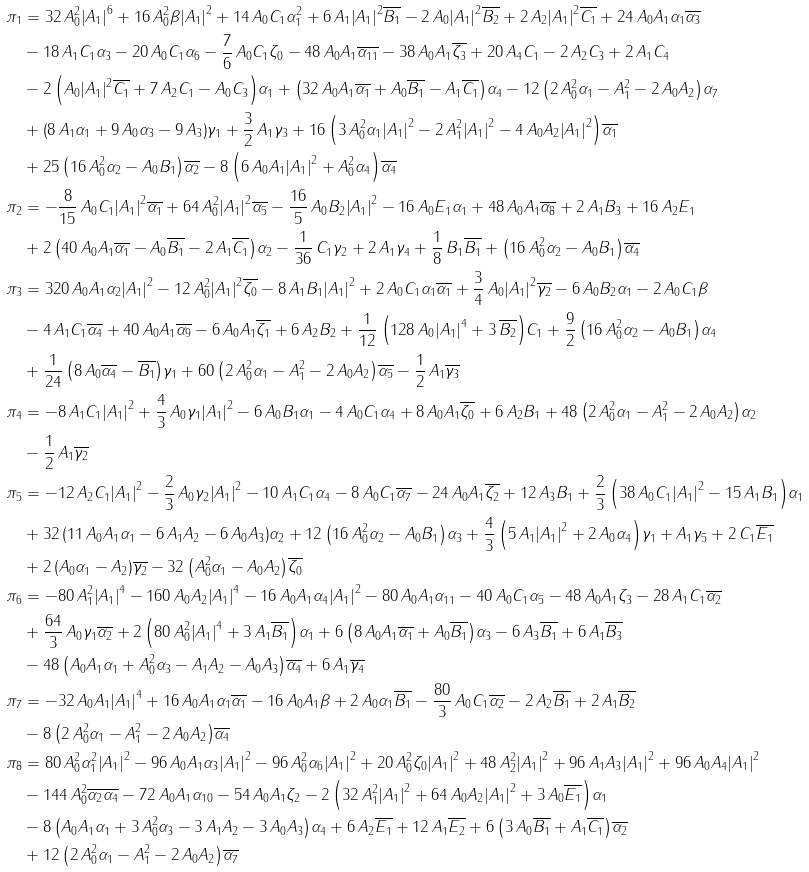<formula> <loc_0><loc_0><loc_500><loc_500>\pi _ { 1 } & = 3 2 \, A _ { 0 } ^ { 2 } { \left | A _ { 1 } \right | } ^ { 6 } + 1 6 \, A _ { 0 } ^ { 2 } \beta { \left | A _ { 1 } \right | } ^ { 2 } + 1 4 \, A _ { 0 } C _ { 1 } \alpha _ { 1 } ^ { 2 } + 6 \, A _ { 1 } { \left | A _ { 1 } \right | } ^ { 2 } \overline { B _ { 1 } } - 2 \, A _ { 0 } { \left | A _ { 1 } \right | } ^ { 2 } \overline { B _ { 2 } } + 2 \, A _ { 2 } { \left | A _ { 1 } \right | } ^ { 2 } \overline { C _ { 1 } } + 2 4 \, A _ { 0 } A _ { 1 } \alpha _ { 1 } \overline { \alpha _ { 3 } } \\ & - 1 8 \, A _ { 1 } C _ { 1 } \alpha _ { 3 } - 2 0 \, A _ { 0 } C _ { 1 } \alpha _ { 6 } - \frac { 7 } { 6 } \, A _ { 0 } C _ { 1 } \zeta _ { 0 } - 4 8 \, A _ { 0 } A _ { 1 } \overline { \alpha _ { 1 1 } } - 3 8 \, A _ { 0 } A _ { 1 } \overline { \zeta _ { 3 } } + 2 0 \, A _ { 4 } C _ { 1 } - 2 \, A _ { 2 } C _ { 3 } + 2 \, A _ { 1 } C _ { 4 } \\ & - 2 \, { \left ( A _ { 0 } { \left | A _ { 1 } \right | } ^ { 2 } \overline { C _ { 1 } } + 7 \, A _ { 2 } C _ { 1 } - A _ { 0 } C _ { 3 } \right ) } \alpha _ { 1 } + { \left ( 3 2 \, A _ { 0 } A _ { 1 } \overline { \alpha _ { 1 } } + A _ { 0 } \overline { B _ { 1 } } - A _ { 1 } \overline { C _ { 1 } } \right ) } \alpha _ { 4 } - 1 2 \, { \left ( 2 \, A _ { 0 } ^ { 2 } \alpha _ { 1 } - A _ { 1 } ^ { 2 } - 2 \, A _ { 0 } A _ { 2 } \right ) } \alpha _ { 7 } \\ & + { \left ( 8 \, A _ { 1 } \alpha _ { 1 } + 9 \, A _ { 0 } \alpha _ { 3 } - 9 \, A _ { 3 } \right ) } \gamma _ { 1 } + \frac { 3 } { 2 } \, A _ { 1 } \gamma _ { 3 } + 1 6 \, { \left ( 3 \, A _ { 0 } ^ { 2 } \alpha _ { 1 } { \left | A _ { 1 } \right | } ^ { 2 } - 2 \, A _ { 1 } ^ { 2 } { \left | A _ { 1 } \right | } ^ { 2 } - 4 \, A _ { 0 } A _ { 2 } { \left | A _ { 1 } \right | } ^ { 2 } \right ) } \overline { \alpha _ { 1 } } \\ & + 2 5 \, { \left ( 1 6 \, A _ { 0 } ^ { 2 } \alpha _ { 2 } - A _ { 0 } B _ { 1 } \right ) } \overline { \alpha _ { 2 } } - 8 \, { \left ( 6 \, A _ { 0 } A _ { 1 } { \left | A _ { 1 } \right | } ^ { 2 } + A _ { 0 } ^ { 2 } \alpha _ { 4 } \right ) } \overline { \alpha _ { 4 } } \\ \pi _ { 2 } & = - \frac { 8 } { 1 5 } \, A _ { 0 } C _ { 1 } { \left | A _ { 1 } \right | } ^ { 2 } \overline { \alpha _ { 1 } } + 6 4 \, A _ { 0 } ^ { 2 } { \left | A _ { 1 } \right | } ^ { 2 } \overline { \alpha _ { 5 } } - \frac { 1 6 } { 5 } \, A _ { 0 } B _ { 2 } { \left | A _ { 1 } \right | } ^ { 2 } - 1 6 \, A _ { 0 } E _ { 1 } \alpha _ { 1 } + 4 8 \, A _ { 0 } A _ { 1 } \overline { \alpha _ { 8 } } + 2 \, A _ { 1 } B _ { 3 } + 1 6 \, A _ { 2 } E _ { 1 } \\ & + 2 \, { \left ( 4 0 \, A _ { 0 } A _ { 1 } \overline { \alpha _ { 1 } } - A _ { 0 } \overline { B _ { 1 } } - 2 \, A _ { 1 } \overline { C _ { 1 } } \right ) } \alpha _ { 2 } - \frac { 1 } { 3 6 } \, C _ { 1 } \gamma _ { 2 } + 2 \, A _ { 1 } \gamma _ { 4 } + \frac { 1 } { 8 } \, B _ { 1 } \overline { B _ { 1 } } + { \left ( 1 6 \, A _ { 0 } ^ { 2 } \alpha _ { 2 } - A _ { 0 } B _ { 1 } \right ) } \overline { \alpha _ { 4 } } \\ \pi _ { 3 } & = 3 2 0 \, A _ { 0 } A _ { 1 } \alpha _ { 2 } { \left | A _ { 1 } \right | } ^ { 2 } - 1 2 \, A _ { 0 } ^ { 2 } { \left | A _ { 1 } \right | } ^ { 2 } \overline { \zeta _ { 0 } } - 8 \, A _ { 1 } B _ { 1 } { \left | A _ { 1 } \right | } ^ { 2 } + 2 \, A _ { 0 } C _ { 1 } \alpha _ { 1 } \overline { \alpha _ { 1 } } + \frac { 3 } { 4 } \, A _ { 0 } { \left | A _ { 1 } \right | } ^ { 2 } \overline { \gamma _ { 2 } } - 6 \, A _ { 0 } B _ { 2 } \alpha _ { 1 } - 2 \, A _ { 0 } C _ { 1 } \beta \\ & - 4 \, A _ { 1 } C _ { 1 } \overline { \alpha _ { 4 } } + 4 0 \, A _ { 0 } A _ { 1 } \overline { \alpha _ { 9 } } - 6 \, A _ { 0 } A _ { 1 } \overline { \zeta _ { 1 } } + 6 \, A _ { 2 } B _ { 2 } + \frac { 1 } { 1 2 } \, { \left ( 1 2 8 \, A _ { 0 } { \left | A _ { 1 } \right | } ^ { 4 } + 3 \, \overline { B _ { 2 } } \right ) } C _ { 1 } + \frac { 9 } { 2 } \, { \left ( 1 6 \, A _ { 0 } ^ { 2 } \alpha _ { 2 } - A _ { 0 } B _ { 1 } \right ) } \alpha _ { 4 } \\ & + \frac { 1 } { 2 4 } \, { \left ( 8 \, A _ { 0 } \overline { \alpha _ { 4 } } - \overline { B _ { 1 } } \right ) } \gamma _ { 1 } + 6 0 \, { \left ( 2 \, A _ { 0 } ^ { 2 } \alpha _ { 1 } - A _ { 1 } ^ { 2 } - 2 \, A _ { 0 } A _ { 2 } \right ) } \overline { \alpha _ { 5 } } - \frac { 1 } { 2 } \, A _ { 1 } \overline { \gamma _ { 3 } } \\ \pi _ { 4 } & = - 8 \, A _ { 1 } C _ { 1 } { \left | A _ { 1 } \right | } ^ { 2 } + \frac { 4 } { 3 } \, A _ { 0 } \gamma _ { 1 } { \left | A _ { 1 } \right | } ^ { 2 } - 6 \, A _ { 0 } B _ { 1 } \alpha _ { 1 } - 4 \, A _ { 0 } C _ { 1 } \alpha _ { 4 } + 8 \, A _ { 0 } A _ { 1 } \overline { \zeta _ { 0 } } + 6 \, A _ { 2 } B _ { 1 } + 4 8 \, { \left ( 2 \, A _ { 0 } ^ { 2 } \alpha _ { 1 } - A _ { 1 } ^ { 2 } - 2 \, A _ { 0 } A _ { 2 } \right ) } \alpha _ { 2 } \\ & - \frac { 1 } { 2 } \, A _ { 1 } \overline { \gamma _ { 2 } } \\ \pi _ { 5 } & = - 1 2 \, A _ { 2 } C _ { 1 } { \left | A _ { 1 } \right | } ^ { 2 } - \frac { 2 } { 3 } \, A _ { 0 } \gamma _ { 2 } { \left | A _ { 1 } \right | } ^ { 2 } - 1 0 \, A _ { 1 } C _ { 1 } \alpha _ { 4 } - 8 \, A _ { 0 } C _ { 1 } \overline { \alpha _ { 7 } } - 2 4 \, A _ { 0 } A _ { 1 } \overline { \zeta _ { 2 } } + 1 2 \, A _ { 3 } B _ { 1 } + \frac { 2 } { 3 } \, { \left ( 3 8 \, A _ { 0 } C _ { 1 } { \left | A _ { 1 } \right | } ^ { 2 } - 1 5 \, A _ { 1 } B _ { 1 } \right ) } \alpha _ { 1 } \\ & + 3 2 \, { \left ( 1 1 \, A _ { 0 } A _ { 1 } \alpha _ { 1 } - 6 \, A _ { 1 } A _ { 2 } - 6 \, A _ { 0 } A _ { 3 } \right ) } \alpha _ { 2 } + 1 2 \, { \left ( 1 6 \, A _ { 0 } ^ { 2 } \alpha _ { 2 } - A _ { 0 } B _ { 1 } \right ) } \alpha _ { 3 } + \frac { 4 } { 3 } \, { \left ( 5 \, A _ { 1 } { \left | A _ { 1 } \right | } ^ { 2 } + 2 \, A _ { 0 } \alpha _ { 4 } \right ) } \gamma _ { 1 } + A _ { 1 } \gamma _ { 5 } + 2 \, C _ { 1 } \overline { E _ { 1 } } \\ & + 2 \, { \left ( A _ { 0 } \alpha _ { 1 } - A _ { 2 } \right ) } \overline { \gamma _ { 2 } } - 3 2 \, { \left ( A _ { 0 } ^ { 2 } \alpha _ { 1 } - A _ { 0 } A _ { 2 } \right ) } \overline { \zeta _ { 0 } } \\ \pi _ { 6 } & = - 8 0 \, A _ { 1 } ^ { 2 } { \left | A _ { 1 } \right | } ^ { 4 } - 1 6 0 \, A _ { 0 } A _ { 2 } { \left | A _ { 1 } \right | } ^ { 4 } - 1 6 \, A _ { 0 } A _ { 1 } \alpha _ { 4 } { \left | A _ { 1 } \right | } ^ { 2 } - 8 0 \, A _ { 0 } A _ { 1 } \alpha _ { 1 1 } - 4 0 \, A _ { 0 } C _ { 1 } \alpha _ { 5 } - 4 8 \, A _ { 0 } A _ { 1 } \zeta _ { 3 } - 2 8 \, A _ { 1 } C _ { 1 } \overline { \alpha _ { 2 } } \\ & + \frac { 6 4 } { 3 } \, A _ { 0 } \gamma _ { 1 } \overline { \alpha _ { 2 } } + 2 \, { \left ( 8 0 \, A _ { 0 } ^ { 2 } { \left | A _ { 1 } \right | } ^ { 4 } + 3 \, A _ { 1 } \overline { B _ { 1 } } \right ) } \alpha _ { 1 } + 6 \, { \left ( 8 \, A _ { 0 } A _ { 1 } \overline { \alpha _ { 1 } } + A _ { 0 } \overline { B _ { 1 } } \right ) } \alpha _ { 3 } - 6 \, A _ { 3 } \overline { B _ { 1 } } + 6 \, A _ { 1 } \overline { B _ { 3 } } \\ & - 4 8 \, { \left ( A _ { 0 } A _ { 1 } \alpha _ { 1 } + A _ { 0 } ^ { 2 } \alpha _ { 3 } - A _ { 1 } A _ { 2 } - A _ { 0 } A _ { 3 } \right ) } \overline { \alpha _ { 4 } } + 6 \, A _ { 1 } \overline { \gamma _ { 4 } } \\ \pi _ { 7 } & = - 3 2 \, A _ { 0 } A _ { 1 } { \left | A _ { 1 } \right | } ^ { 4 } + 1 6 \, A _ { 0 } A _ { 1 } \alpha _ { 1 } \overline { \alpha _ { 1 } } - 1 6 \, A _ { 0 } A _ { 1 } \beta + 2 \, A _ { 0 } \alpha _ { 1 } \overline { B _ { 1 } } - \frac { 8 0 } { 3 } \, A _ { 0 } C _ { 1 } \overline { \alpha _ { 2 } } - 2 \, A _ { 2 } \overline { B _ { 1 } } + 2 \, A _ { 1 } \overline { B _ { 2 } } \\ & - 8 \, { \left ( 2 \, A _ { 0 } ^ { 2 } \alpha _ { 1 } - A _ { 1 } ^ { 2 } - 2 \, A _ { 0 } A _ { 2 } \right ) } \overline { \alpha _ { 4 } } \\ \pi _ { 8 } & = 8 0 \, A _ { 0 } ^ { 2 } \alpha _ { 1 } ^ { 2 } { \left | A _ { 1 } \right | } ^ { 2 } - 9 6 \, A _ { 0 } A _ { 1 } \alpha _ { 3 } { \left | A _ { 1 } \right | } ^ { 2 } - 9 6 \, A _ { 0 } ^ { 2 } \alpha _ { 6 } { \left | A _ { 1 } \right | } ^ { 2 } + 2 0 \, A _ { 0 } ^ { 2 } \zeta _ { 0 } { \left | A _ { 1 } \right | } ^ { 2 } + 4 8 \, A _ { 2 } ^ { 2 } { \left | A _ { 1 } \right | } ^ { 2 } + 9 6 \, A _ { 1 } A _ { 3 } { \left | A _ { 1 } \right | } ^ { 2 } + 9 6 \, A _ { 0 } A _ { 4 } { \left | A _ { 1 } \right | } ^ { 2 } \\ & - 1 4 4 \, A _ { 0 } ^ { 2 } \overline { \alpha _ { 2 } } \overline { \alpha _ { 4 } } - 7 2 \, A _ { 0 } A _ { 1 } \alpha _ { 1 0 } - 5 4 \, A _ { 0 } A _ { 1 } \zeta _ { 2 } - 2 \, { \left ( 3 2 \, A _ { 1 } ^ { 2 } { \left | A _ { 1 } \right | } ^ { 2 } + 6 4 \, A _ { 0 } A _ { 2 } { \left | A _ { 1 } \right | } ^ { 2 } + 3 \, A _ { 0 } \overline { E _ { 1 } } \right ) } \alpha _ { 1 } \\ & - 8 \, { \left ( A _ { 0 } A _ { 1 } \alpha _ { 1 } + 3 \, A _ { 0 } ^ { 2 } \alpha _ { 3 } - 3 \, A _ { 1 } A _ { 2 } - 3 \, A _ { 0 } A _ { 3 } \right ) } \alpha _ { 4 } + 6 \, A _ { 2 } \overline { E _ { 1 } } + 1 2 \, A _ { 1 } \overline { E _ { 2 } } + 6 \, { \left ( 3 \, A _ { 0 } \overline { B _ { 1 } } + A _ { 1 } \overline { C _ { 1 } } \right ) } \overline { \alpha _ { 2 } } \\ & + 1 2 \, { \left ( 2 \, A _ { 0 } ^ { 2 } \alpha _ { 1 } - A _ { 1 } ^ { 2 } - 2 \, A _ { 0 } A _ { 2 } \right ) } \overline { \alpha _ { 7 } }</formula> 